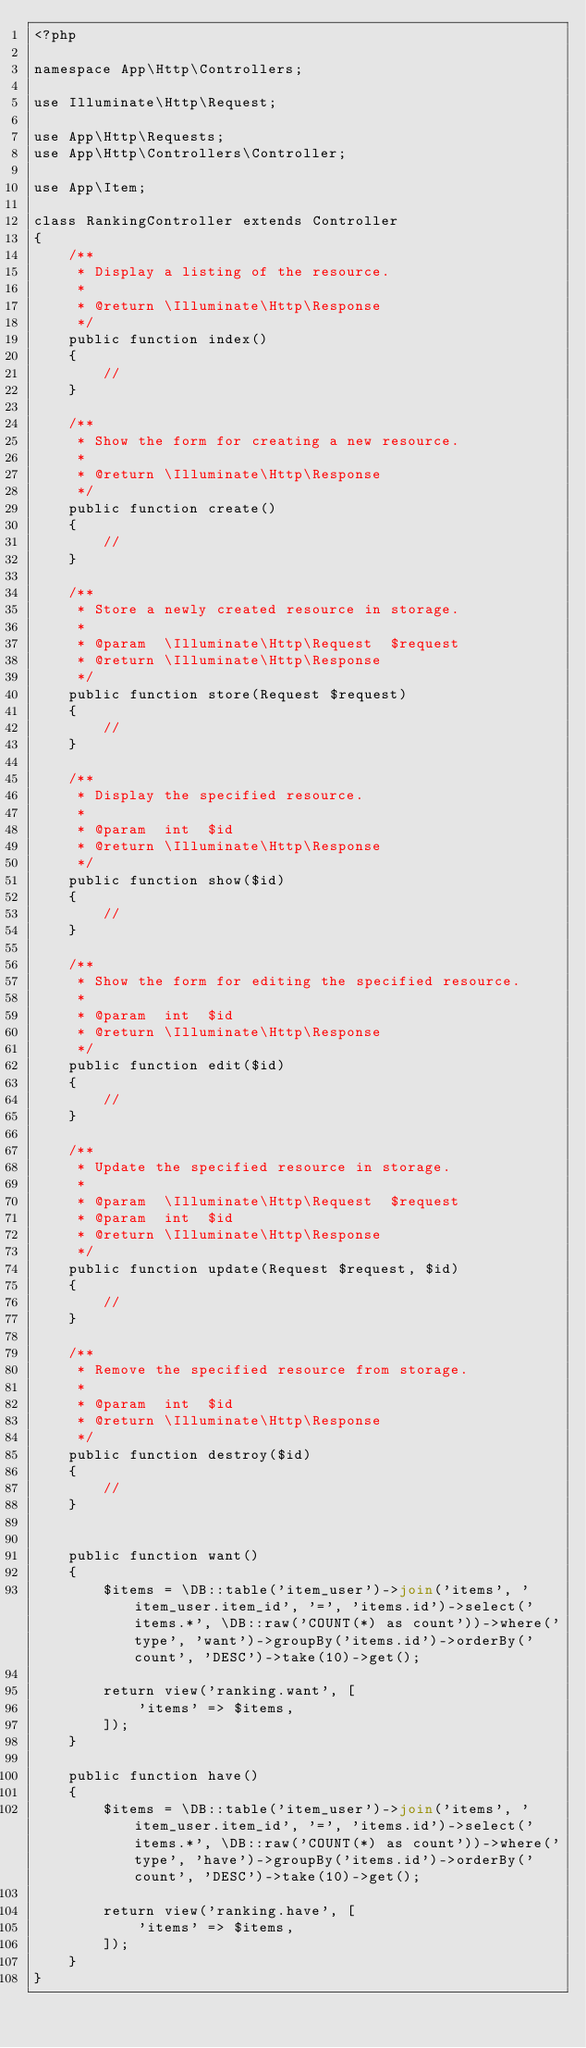Convert code to text. <code><loc_0><loc_0><loc_500><loc_500><_PHP_><?php

namespace App\Http\Controllers;

use Illuminate\Http\Request;

use App\Http\Requests;
use App\Http\Controllers\Controller;

use App\Item;

class RankingController extends Controller
{
    /**
     * Display a listing of the resource.
     *
     * @return \Illuminate\Http\Response
     */
    public function index()
    {
        //
    }

    /**
     * Show the form for creating a new resource.
     *
     * @return \Illuminate\Http\Response
     */
    public function create()
    {
        //
    }

    /**
     * Store a newly created resource in storage.
     *
     * @param  \Illuminate\Http\Request  $request
     * @return \Illuminate\Http\Response
     */
    public function store(Request $request)
    {
        //
    }

    /**
     * Display the specified resource.
     *
     * @param  int  $id
     * @return \Illuminate\Http\Response
     */
    public function show($id)
    {
        //
    }

    /**
     * Show the form for editing the specified resource.
     *
     * @param  int  $id
     * @return \Illuminate\Http\Response
     */
    public function edit($id)
    {
        //
    }

    /**
     * Update the specified resource in storage.
     *
     * @param  \Illuminate\Http\Request  $request
     * @param  int  $id
     * @return \Illuminate\Http\Response
     */
    public function update(Request $request, $id)
    {
        //
    }

    /**
     * Remove the specified resource from storage.
     *
     * @param  int  $id
     * @return \Illuminate\Http\Response
     */
    public function destroy($id)
    {
        //
    }
    
    
    public function want()
    {
        $items = \DB::table('item_user')->join('items', 'item_user.item_id', '=', 'items.id')->select('items.*', \DB::raw('COUNT(*) as count'))->where('type', 'want')->groupBy('items.id')->orderBy('count', 'DESC')->take(10)->get();

        return view('ranking.want', [
            'items' => $items,
        ]);
    }
    
    public function have()
    {
        $items = \DB::table('item_user')->join('items', 'item_user.item_id', '=', 'items.id')->select('items.*', \DB::raw('COUNT(*) as count'))->where('type', 'have')->groupBy('items.id')->orderBy('count', 'DESC')->take(10)->get();

        return view('ranking.have', [
            'items' => $items,
        ]);
    }
}
</code> 